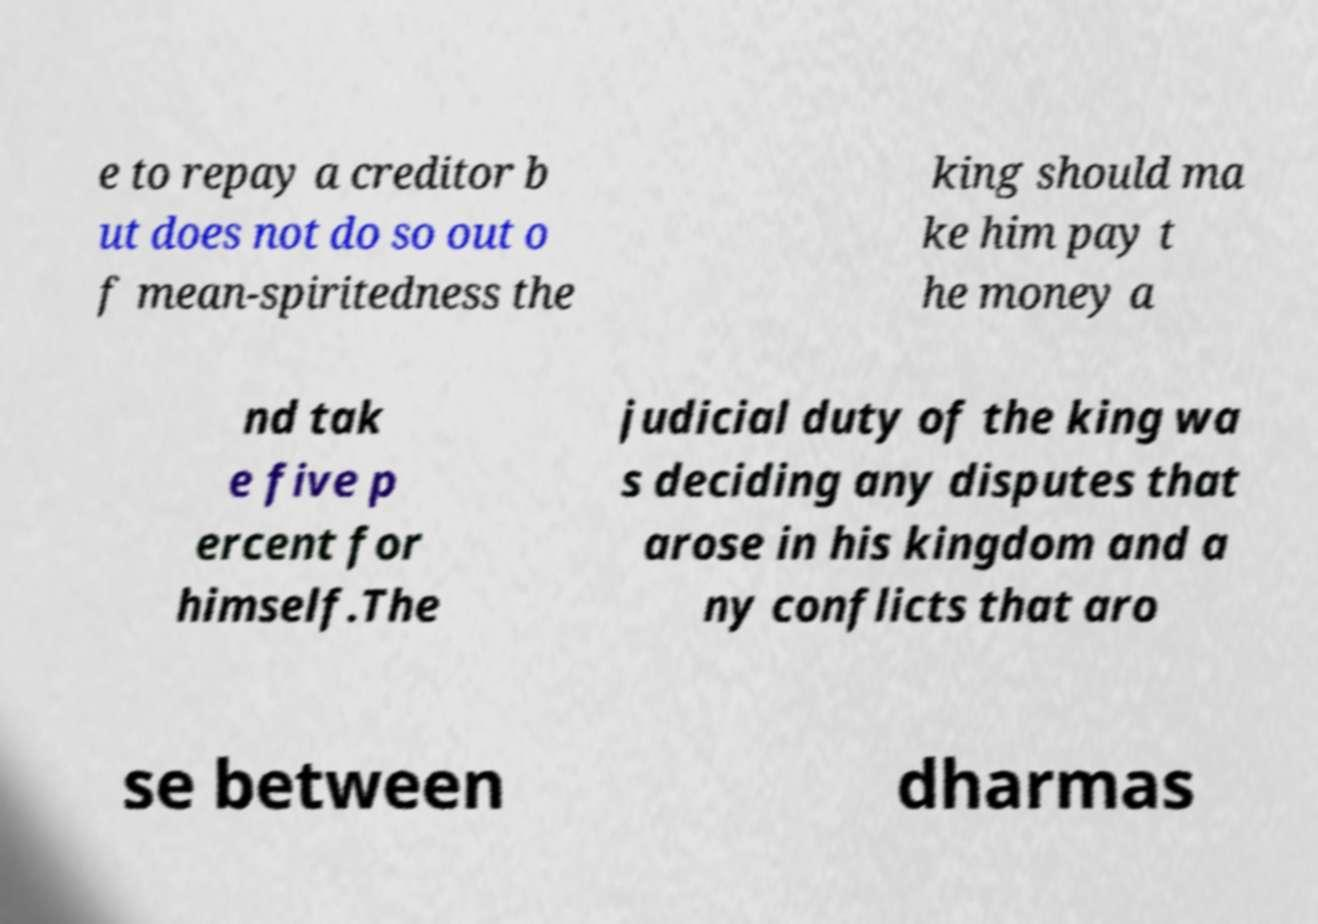Please identify and transcribe the text found in this image. e to repay a creditor b ut does not do so out o f mean-spiritedness the king should ma ke him pay t he money a nd tak e five p ercent for himself.The judicial duty of the king wa s deciding any disputes that arose in his kingdom and a ny conflicts that aro se between dharmas 